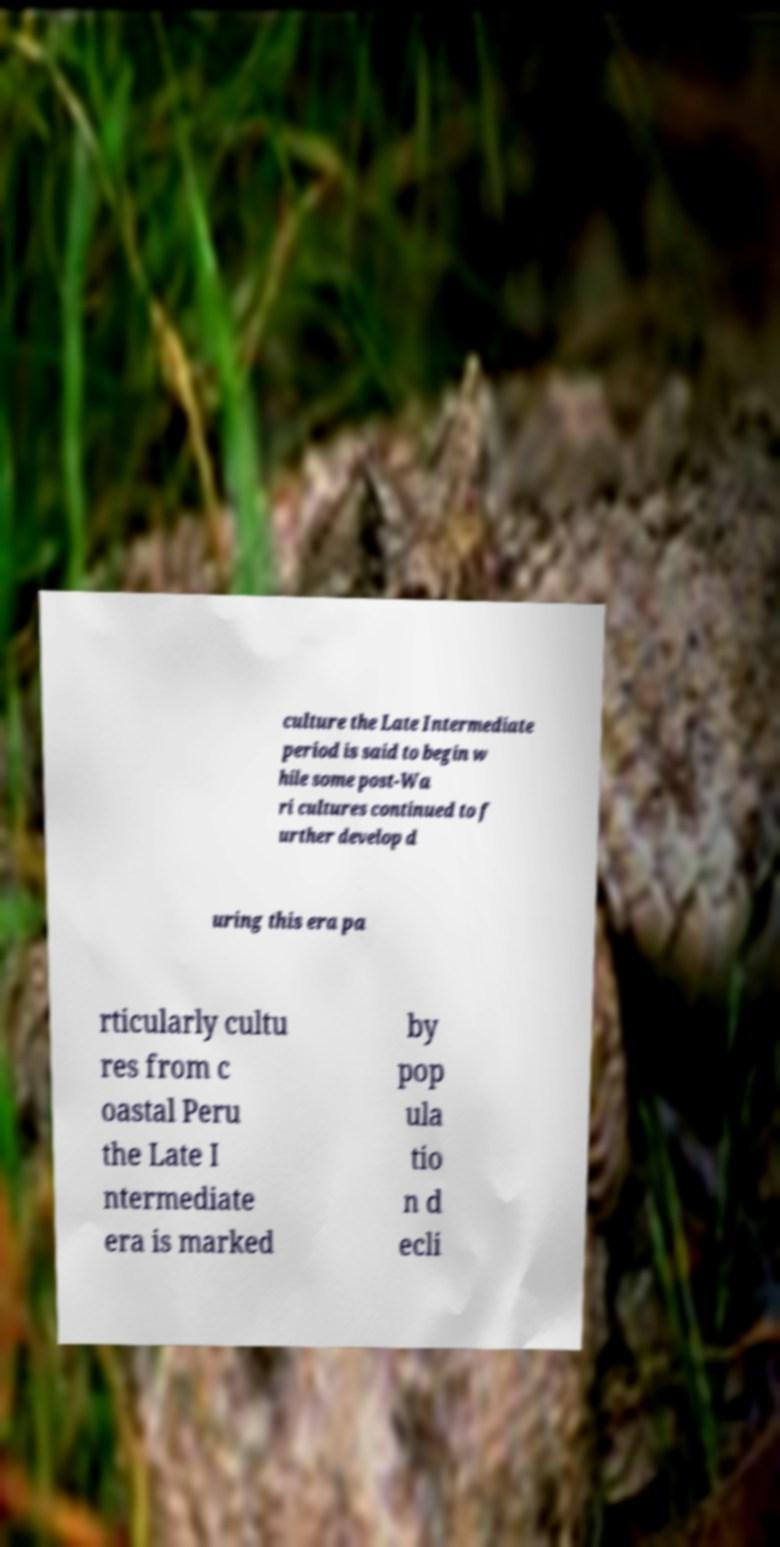I need the written content from this picture converted into text. Can you do that? culture the Late Intermediate period is said to begin w hile some post-Wa ri cultures continued to f urther develop d uring this era pa rticularly cultu res from c oastal Peru the Late I ntermediate era is marked by pop ula tio n d ecli 